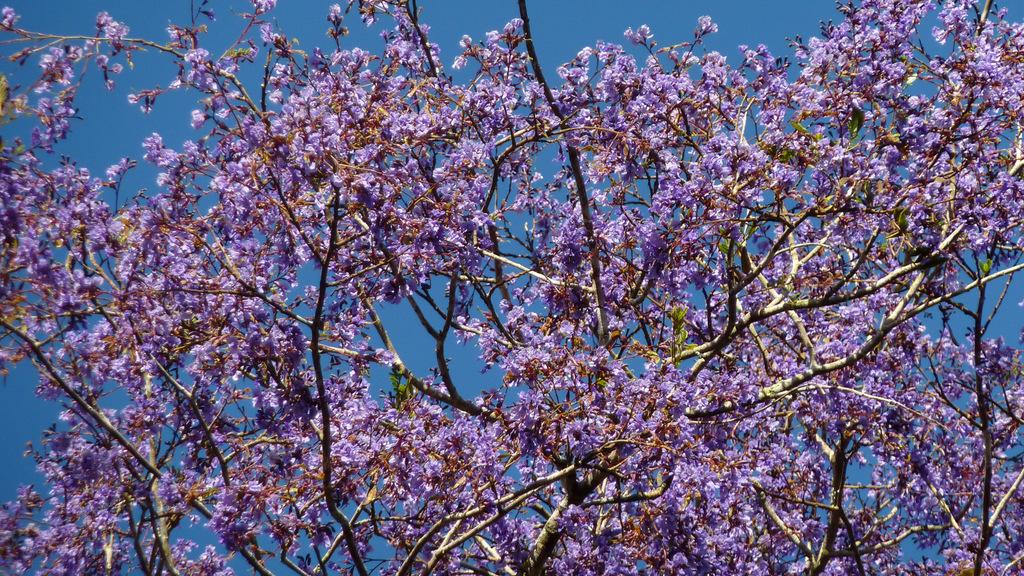What type of plant can be seen in the image? There is a tree in the image. What features of the tree are visible? The tree has branches and flowers. What color are the flowers on the tree? The flowers are violet in color. What else can be seen in the image besides the tree? The sky is visible in the image. What type of peace treaty is being signed under the tree in the image? There is no indication of a peace treaty or any signing event in the image; it simply features a tree with violet flowers and a visible sky. 